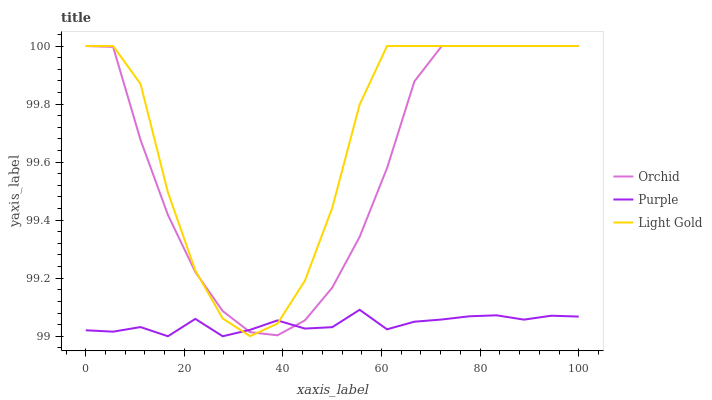Does Purple have the minimum area under the curve?
Answer yes or no. Yes. Does Light Gold have the maximum area under the curve?
Answer yes or no. Yes. Does Orchid have the minimum area under the curve?
Answer yes or no. No. Does Orchid have the maximum area under the curve?
Answer yes or no. No. Is Purple the smoothest?
Answer yes or no. Yes. Is Light Gold the roughest?
Answer yes or no. Yes. Is Orchid the smoothest?
Answer yes or no. No. Is Orchid the roughest?
Answer yes or no. No. Does Purple have the lowest value?
Answer yes or no. Yes. Does Light Gold have the lowest value?
Answer yes or no. No. Does Orchid have the highest value?
Answer yes or no. Yes. Does Light Gold intersect Orchid?
Answer yes or no. Yes. Is Light Gold less than Orchid?
Answer yes or no. No. Is Light Gold greater than Orchid?
Answer yes or no. No. 